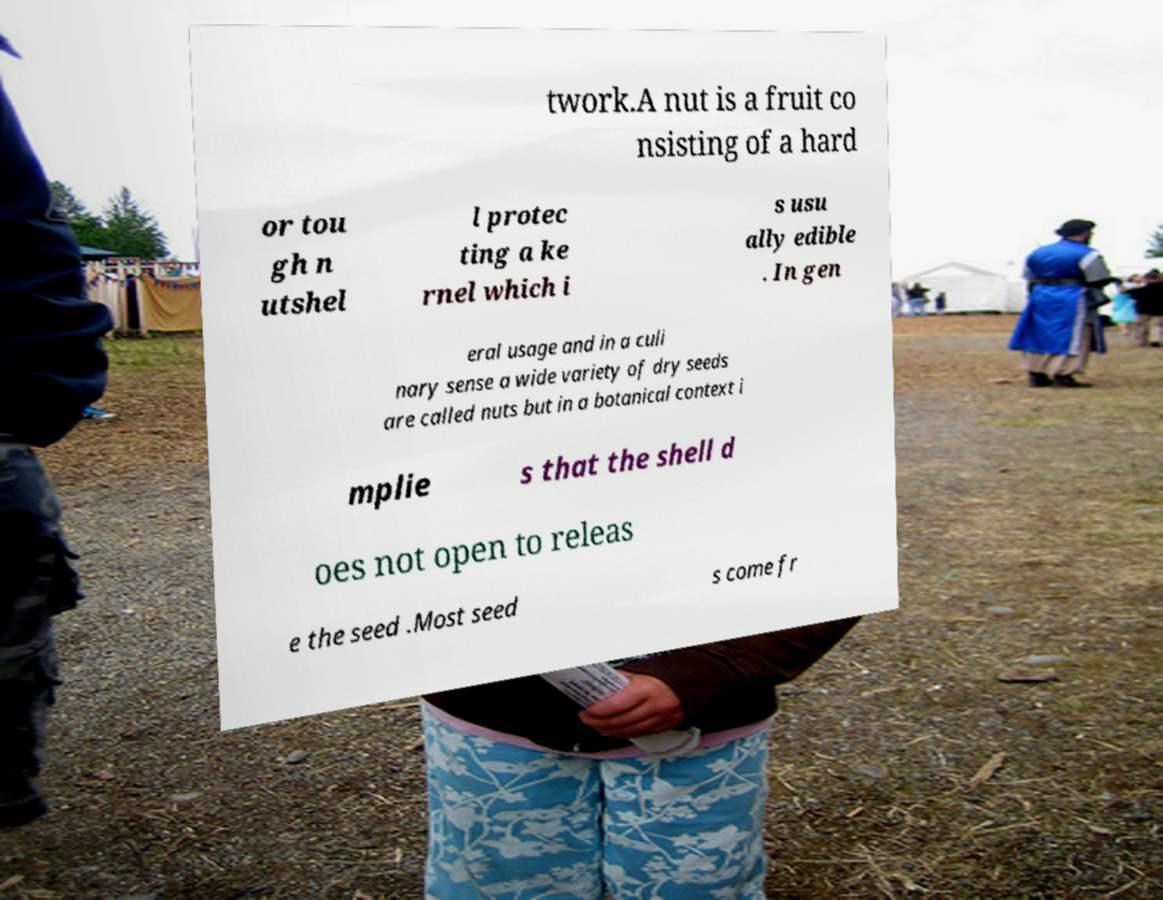Please read and relay the text visible in this image. What does it say? twork.A nut is a fruit co nsisting of a hard or tou gh n utshel l protec ting a ke rnel which i s usu ally edible . In gen eral usage and in a culi nary sense a wide variety of dry seeds are called nuts but in a botanical context i mplie s that the shell d oes not open to releas e the seed .Most seed s come fr 